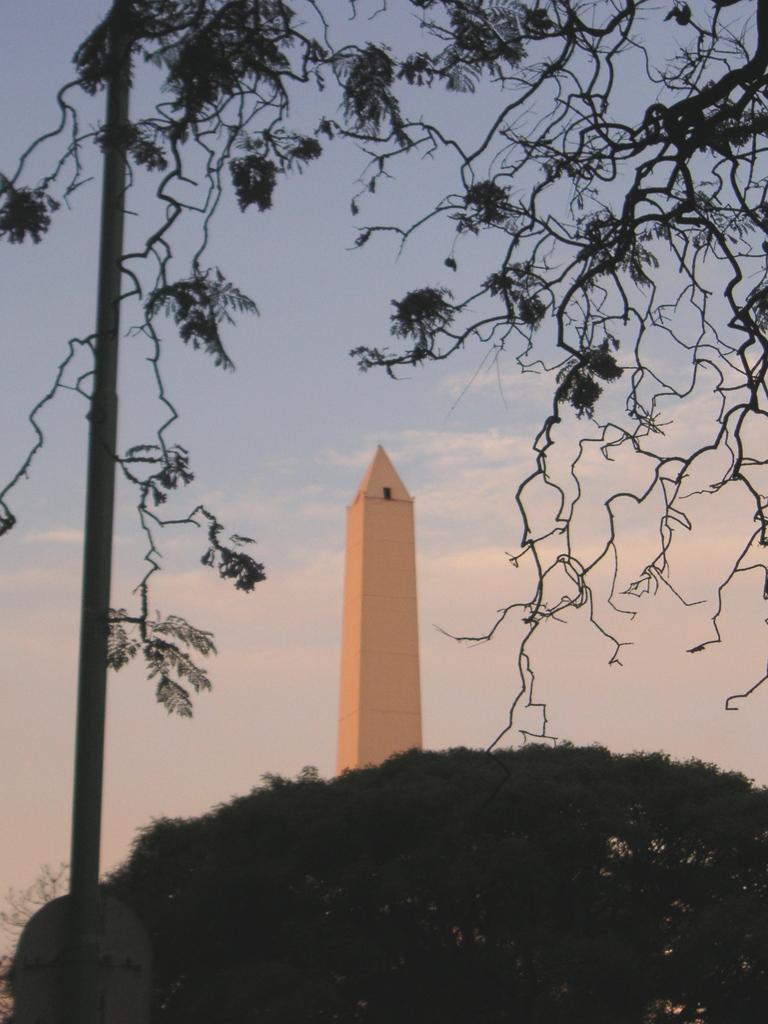In one or two sentences, can you explain what this image depicts? In the foreground of the image we can see a tree. In the middle of the image we can see a tower like building, pole and tree. On the top of the image we can see the sky and the leaves of the tree. 